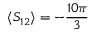<formula> <loc_0><loc_0><loc_500><loc_500>\langle S _ { 1 2 } \rangle = - \frac { 1 0 \pi } { 3 }</formula> 